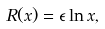<formula> <loc_0><loc_0><loc_500><loc_500>R ( x ) = \epsilon \ln { x } ,</formula> 